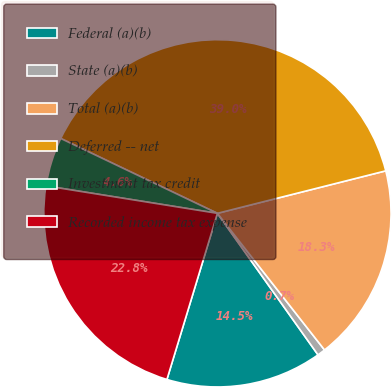Convert chart. <chart><loc_0><loc_0><loc_500><loc_500><pie_chart><fcel>Federal (a)(b)<fcel>State (a)(b)<fcel>Total (a)(b)<fcel>Deferred -- net<fcel>Investment tax credit<fcel>Recorded income tax expense<nl><fcel>14.53%<fcel>0.75%<fcel>18.35%<fcel>38.97%<fcel>4.57%<fcel>22.83%<nl></chart> 